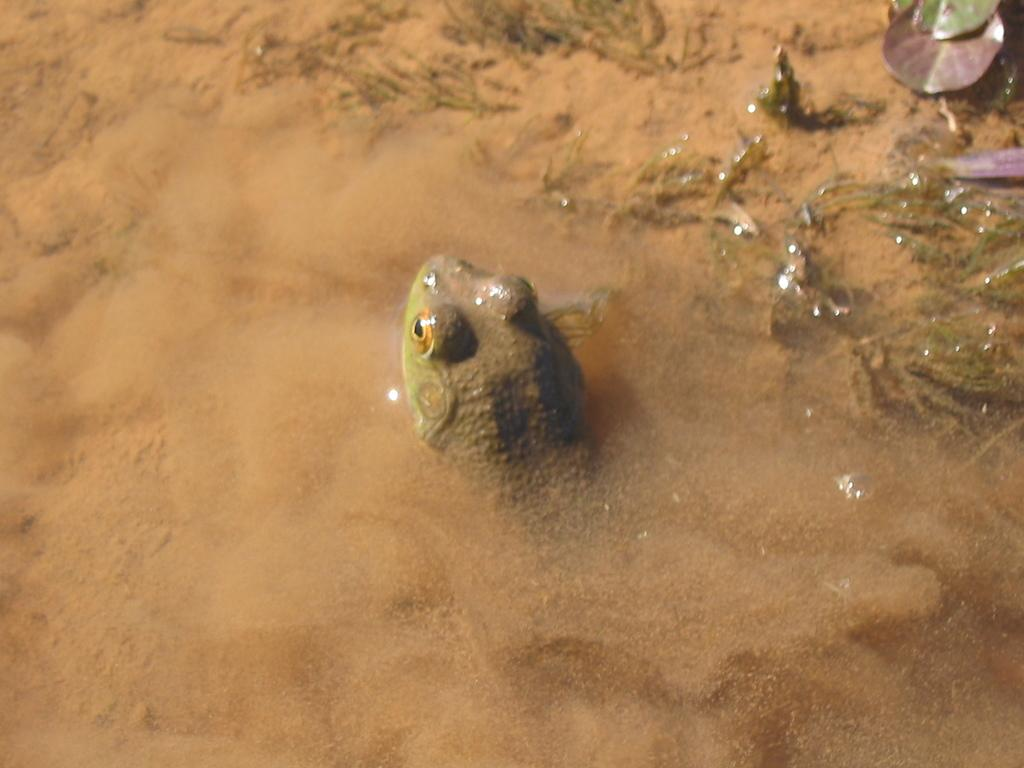What type of terrain is visible in the image? There is sand in the image. What animal can be seen in the image? There is a frog in the image. What type of vegetation is present towards the top of the image? There are plants towards the top of the image. What type of vegetation is present towards the right of the image? There are plants towards the right of the image. What word is written on the frog's back in the image? There are no words written on the frog's back in the image; it is a frog in its natural state. How many dogs are present in the image? There are no dogs present in the image; it features a frog and plants in a sandy environment. 